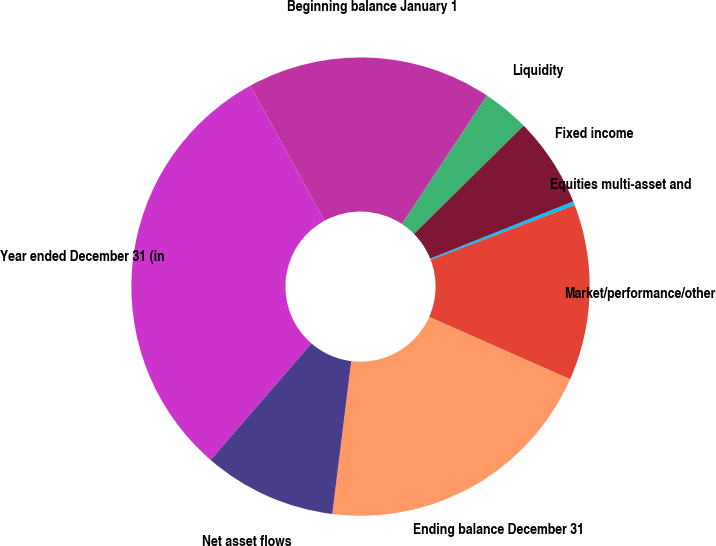Convert chart. <chart><loc_0><loc_0><loc_500><loc_500><pie_chart><fcel>Year ended December 31 (in<fcel>Beginning balance January 1<fcel>Liquidity<fcel>Fixed income<fcel>Equities multi-asset and<fcel>Market/performance/other<fcel>Ending balance December 31<fcel>Net asset flows<nl><fcel>30.67%<fcel>17.29%<fcel>3.3%<fcel>6.34%<fcel>0.26%<fcel>12.42%<fcel>20.34%<fcel>9.38%<nl></chart> 